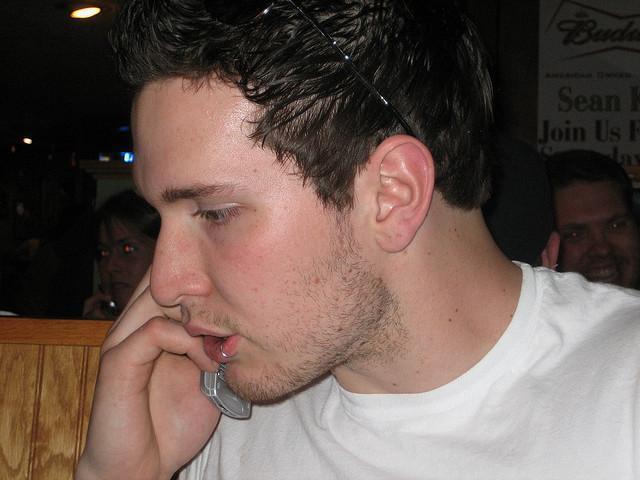What color is the cell phone which the man talks on?
Select the correct answer and articulate reasoning with the following format: 'Answer: answer
Rationale: rationale.'
Options: Pink, white, black, gray. Answer: gray.
Rationale: It's more like a light a or silver even. 